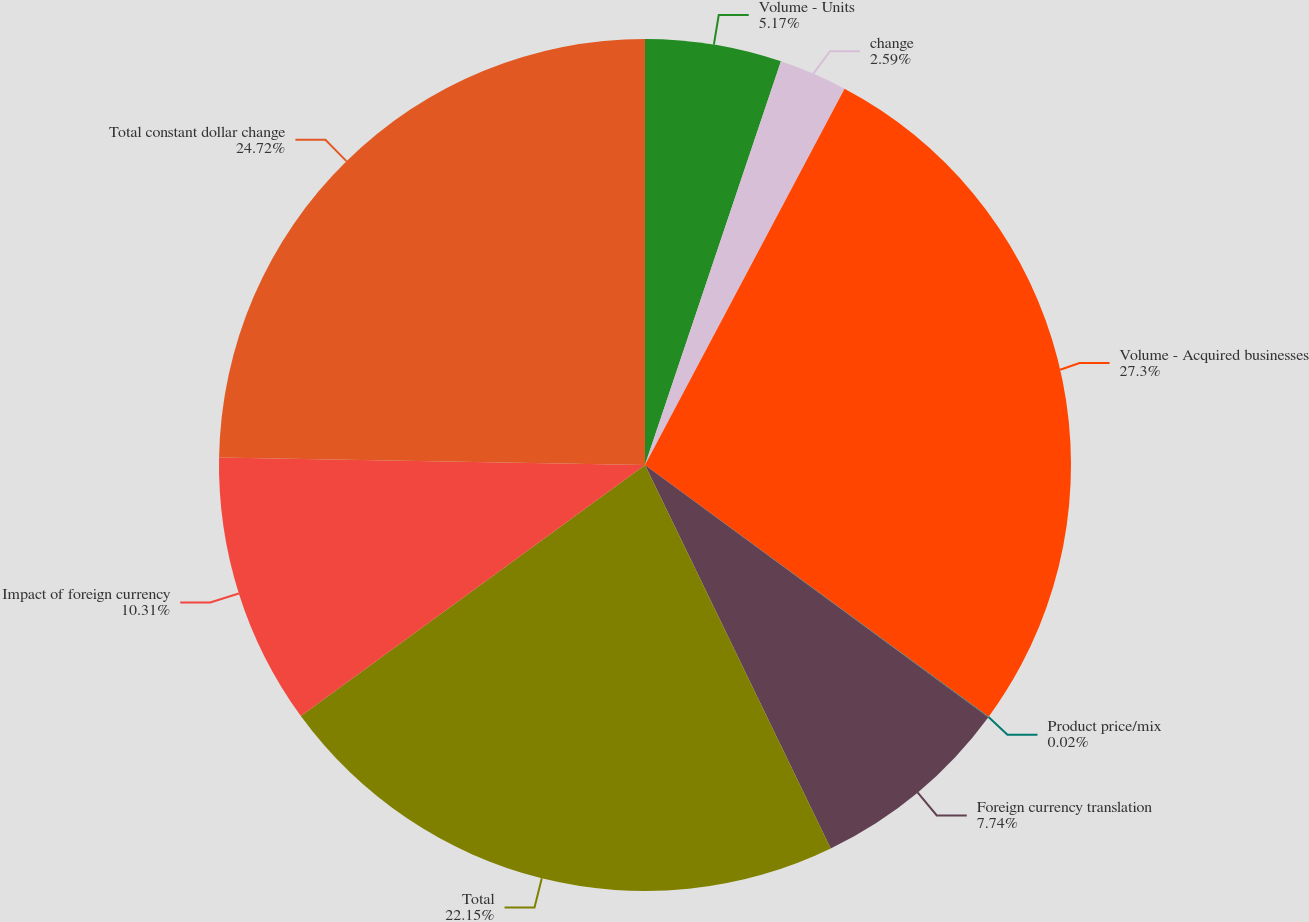Convert chart. <chart><loc_0><loc_0><loc_500><loc_500><pie_chart><fcel>Volume - Units<fcel>change<fcel>Volume - Acquired businesses<fcel>Product price/mix<fcel>Foreign currency translation<fcel>Total<fcel>Impact of foreign currency<fcel>Total constant dollar change<nl><fcel>5.17%<fcel>2.59%<fcel>27.3%<fcel>0.02%<fcel>7.74%<fcel>22.15%<fcel>10.31%<fcel>24.72%<nl></chart> 